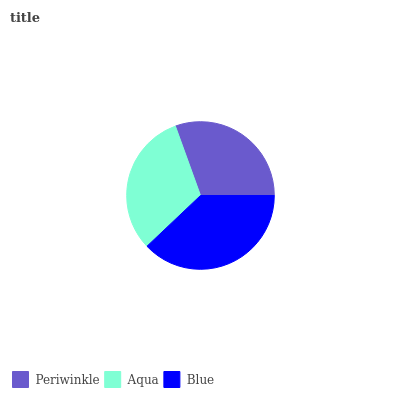Is Periwinkle the minimum?
Answer yes or no. Yes. Is Blue the maximum?
Answer yes or no. Yes. Is Aqua the minimum?
Answer yes or no. No. Is Aqua the maximum?
Answer yes or no. No. Is Aqua greater than Periwinkle?
Answer yes or no. Yes. Is Periwinkle less than Aqua?
Answer yes or no. Yes. Is Periwinkle greater than Aqua?
Answer yes or no. No. Is Aqua less than Periwinkle?
Answer yes or no. No. Is Aqua the high median?
Answer yes or no. Yes. Is Aqua the low median?
Answer yes or no. Yes. Is Blue the high median?
Answer yes or no. No. Is Blue the low median?
Answer yes or no. No. 